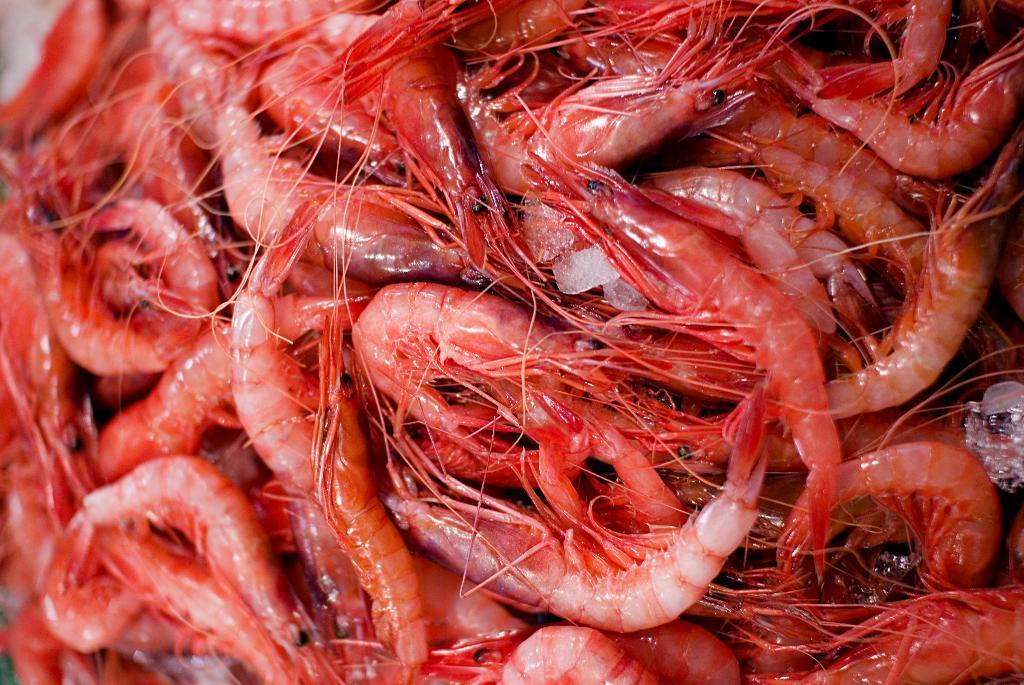Describe this image in one or two sentences. In this image we can see many prawns. 